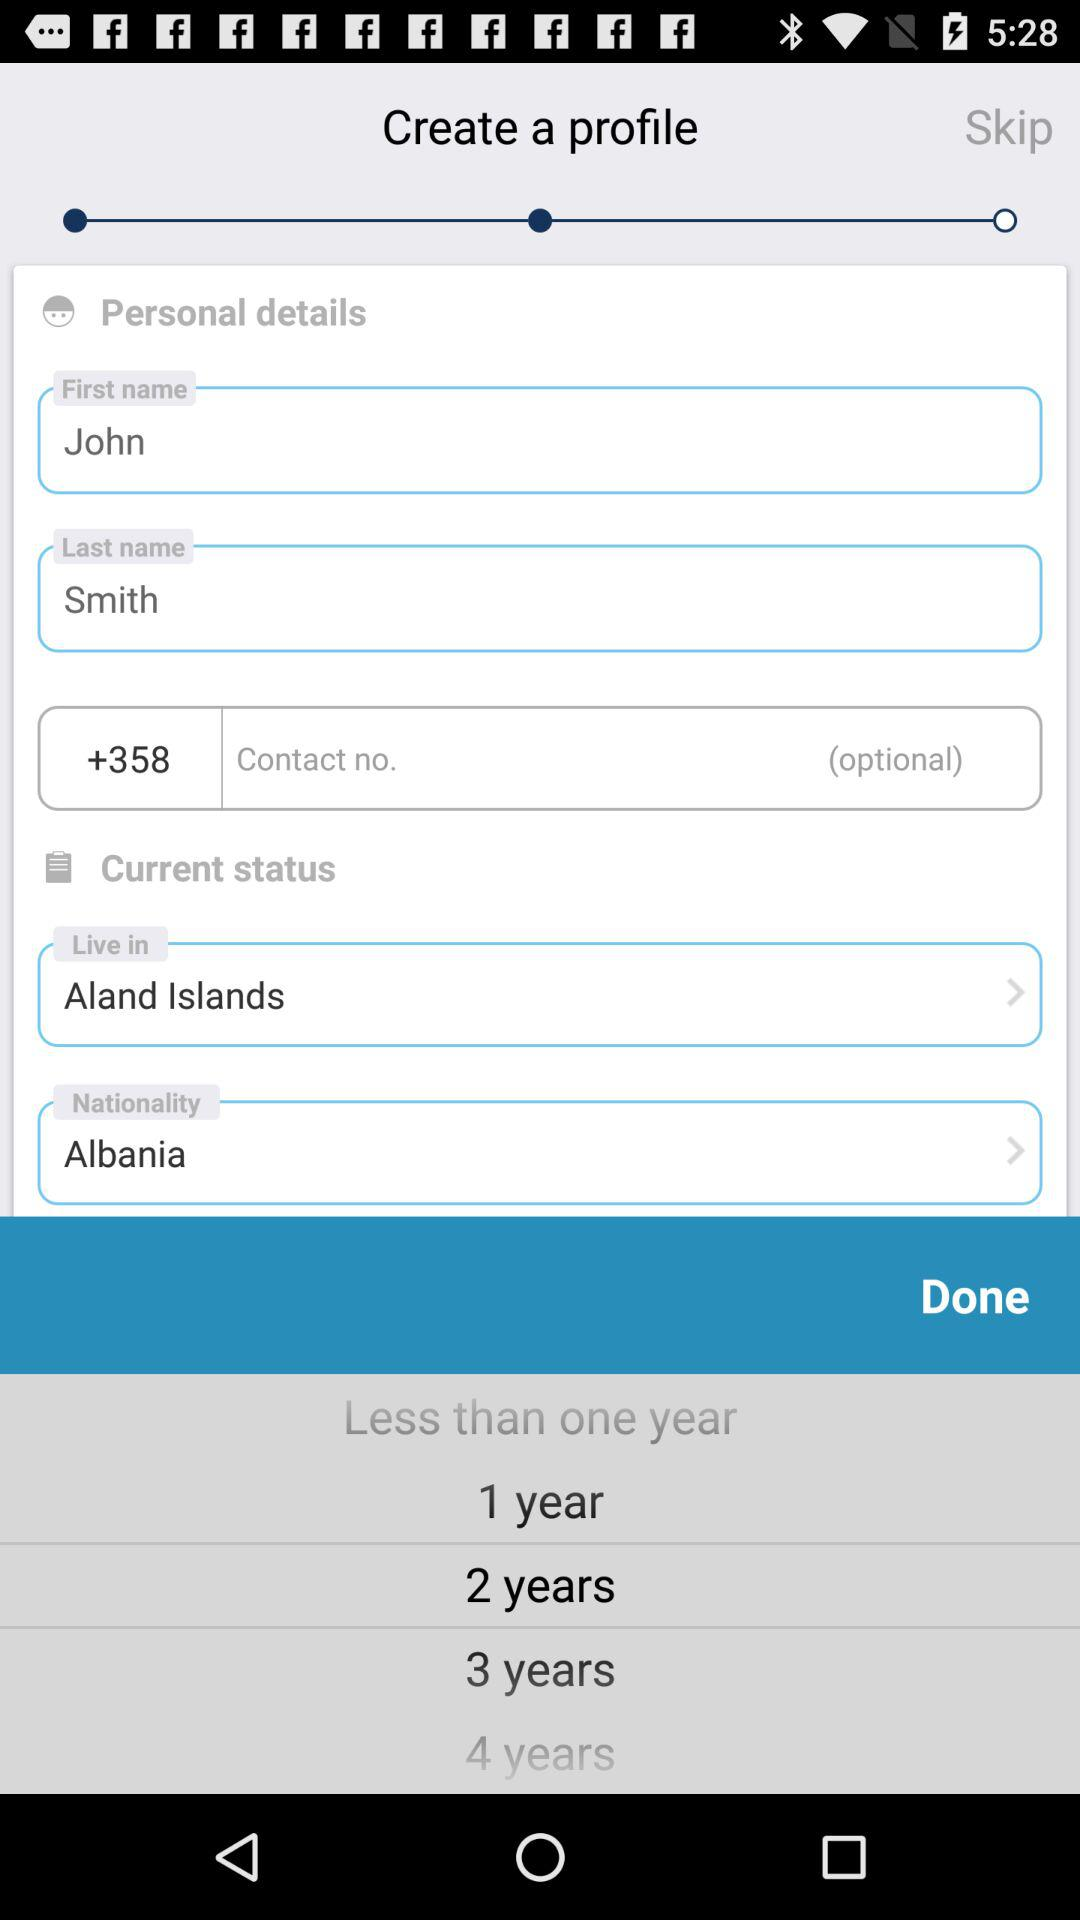What place is entered in "live in"? The place entered in "live in" is the Aland Islands. 